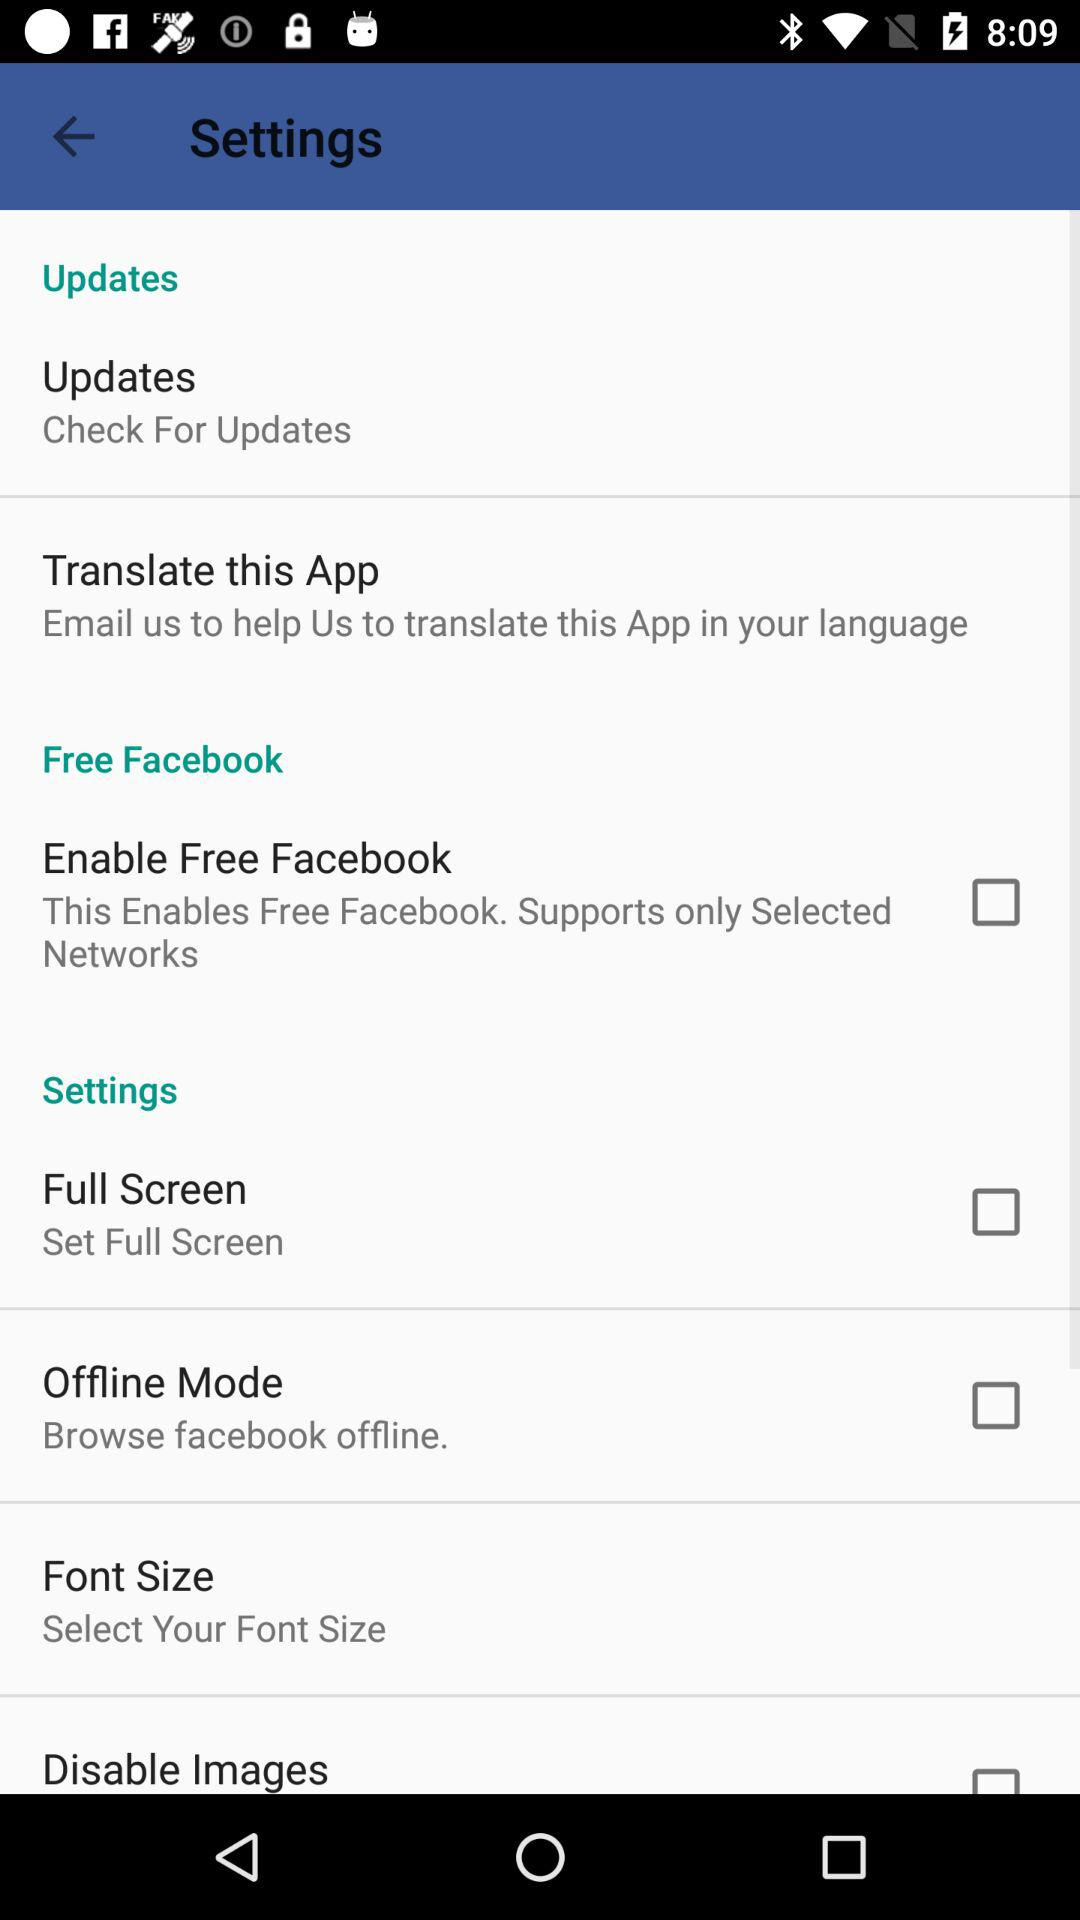What is the status of "Offline Mode"? The status of "Offline Mode" is "off". 